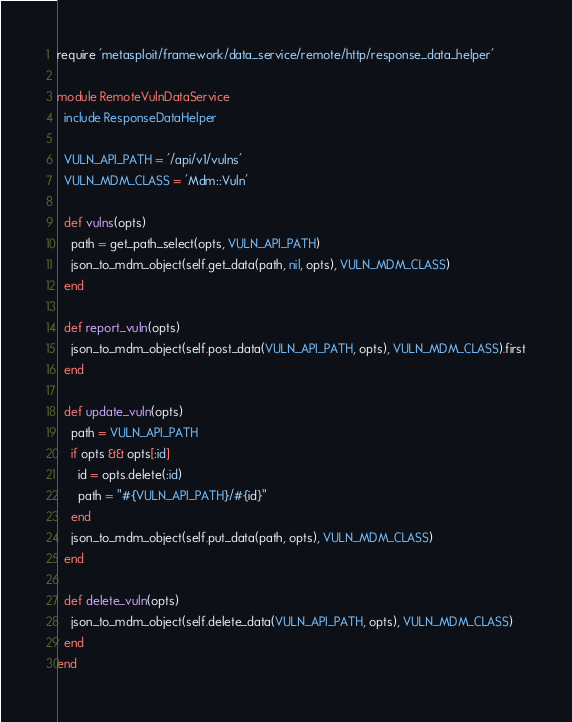Convert code to text. <code><loc_0><loc_0><loc_500><loc_500><_Ruby_>require 'metasploit/framework/data_service/remote/http/response_data_helper'

module RemoteVulnDataService
  include ResponseDataHelper

  VULN_API_PATH = '/api/v1/vulns'
  VULN_MDM_CLASS = 'Mdm::Vuln'

  def vulns(opts)
    path = get_path_select(opts, VULN_API_PATH)
    json_to_mdm_object(self.get_data(path, nil, opts), VULN_MDM_CLASS)
  end

  def report_vuln(opts)
    json_to_mdm_object(self.post_data(VULN_API_PATH, opts), VULN_MDM_CLASS).first
  end

  def update_vuln(opts)
    path = VULN_API_PATH
    if opts && opts[:id]
      id = opts.delete(:id)
      path = "#{VULN_API_PATH}/#{id}"
    end
    json_to_mdm_object(self.put_data(path, opts), VULN_MDM_CLASS)
  end

  def delete_vuln(opts)
    json_to_mdm_object(self.delete_data(VULN_API_PATH, opts), VULN_MDM_CLASS)
  end
end</code> 